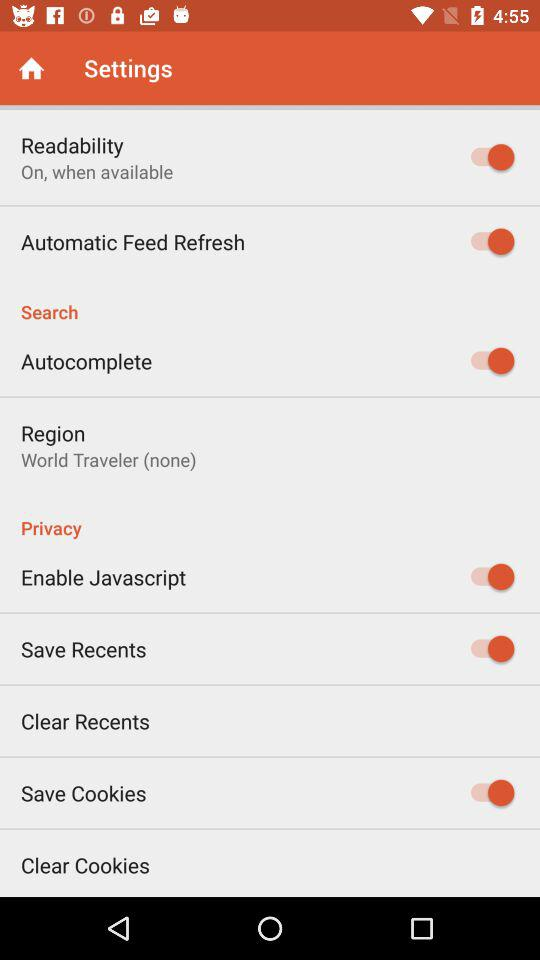What is the setting for region? The setting for region is "World Traveler (none)". 